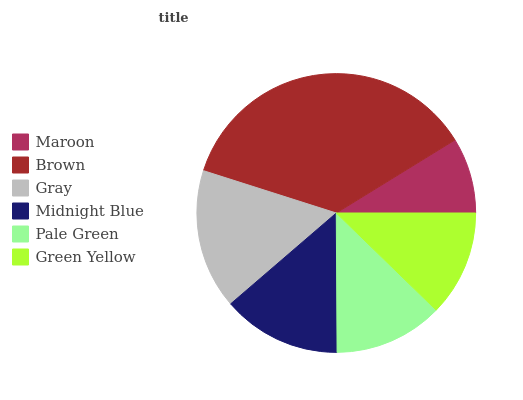Is Maroon the minimum?
Answer yes or no. Yes. Is Brown the maximum?
Answer yes or no. Yes. Is Gray the minimum?
Answer yes or no. No. Is Gray the maximum?
Answer yes or no. No. Is Brown greater than Gray?
Answer yes or no. Yes. Is Gray less than Brown?
Answer yes or no. Yes. Is Gray greater than Brown?
Answer yes or no. No. Is Brown less than Gray?
Answer yes or no. No. Is Midnight Blue the high median?
Answer yes or no. Yes. Is Pale Green the low median?
Answer yes or no. Yes. Is Green Yellow the high median?
Answer yes or no. No. Is Midnight Blue the low median?
Answer yes or no. No. 